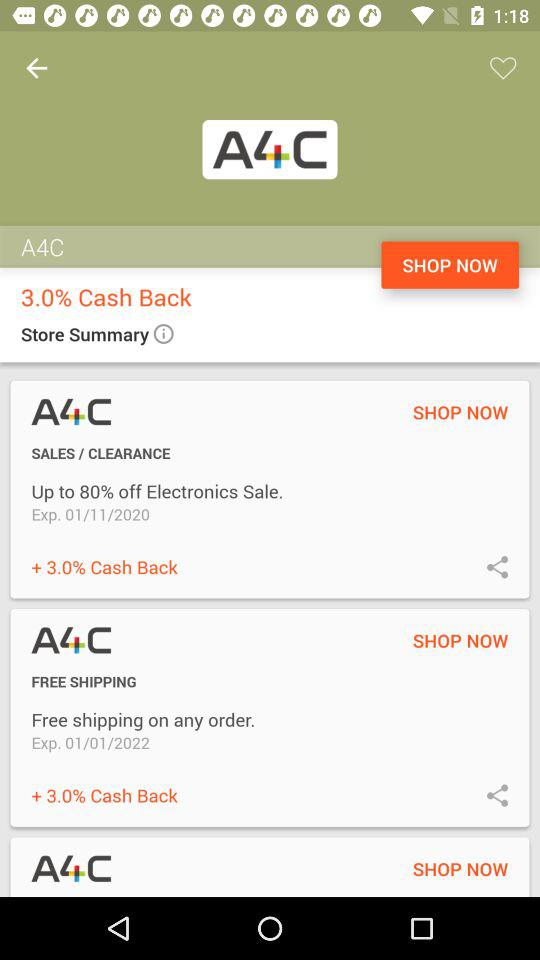How many items have a 3.0% cash back offer?
Answer the question using a single word or phrase. 3 